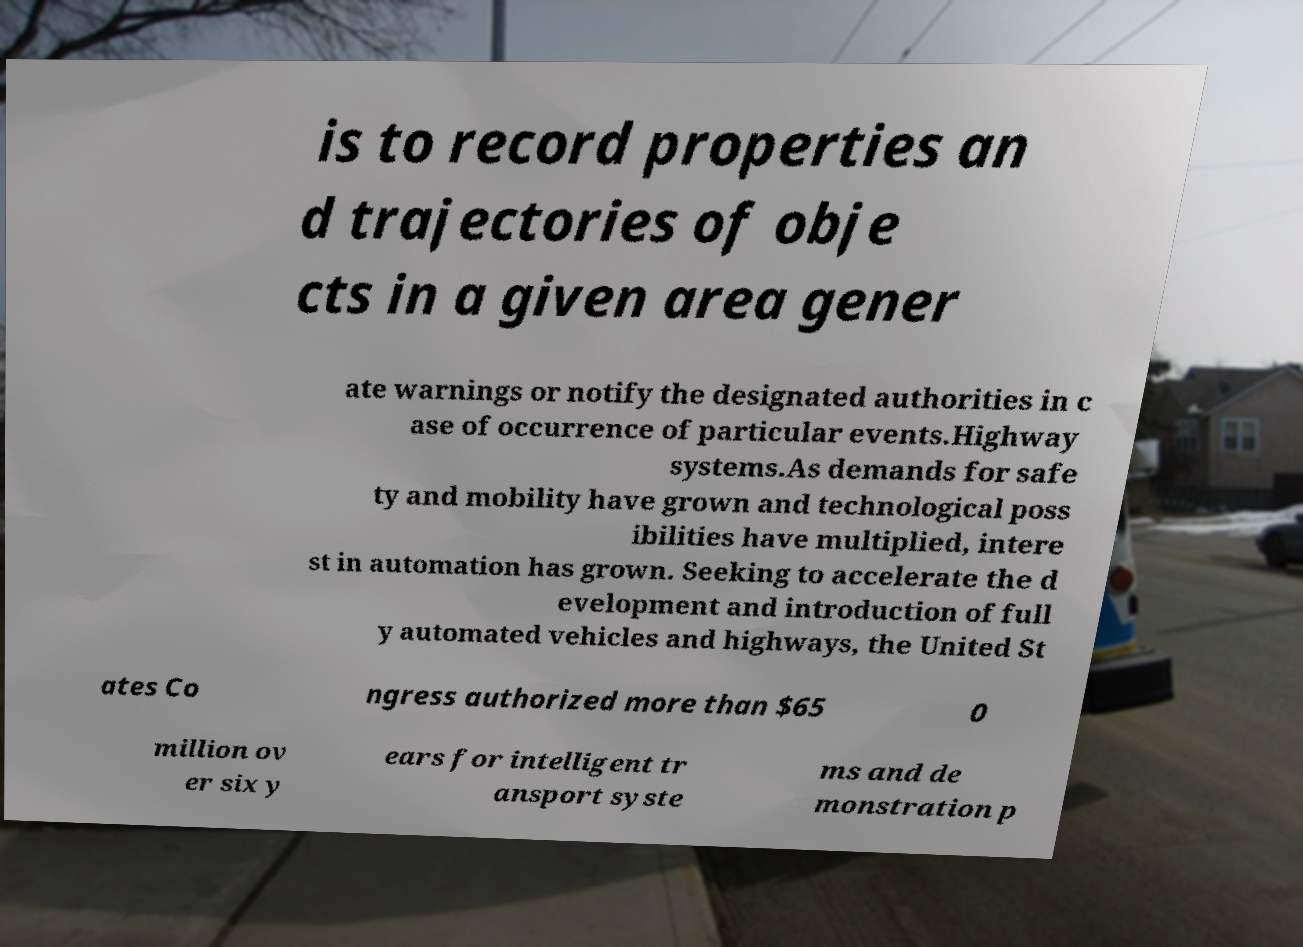Can you accurately transcribe the text from the provided image for me? is to record properties an d trajectories of obje cts in a given area gener ate warnings or notify the designated authorities in c ase of occurrence of particular events.Highway systems.As demands for safe ty and mobility have grown and technological poss ibilities have multiplied, intere st in automation has grown. Seeking to accelerate the d evelopment and introduction of full y automated vehicles and highways, the United St ates Co ngress authorized more than $65 0 million ov er six y ears for intelligent tr ansport syste ms and de monstration p 